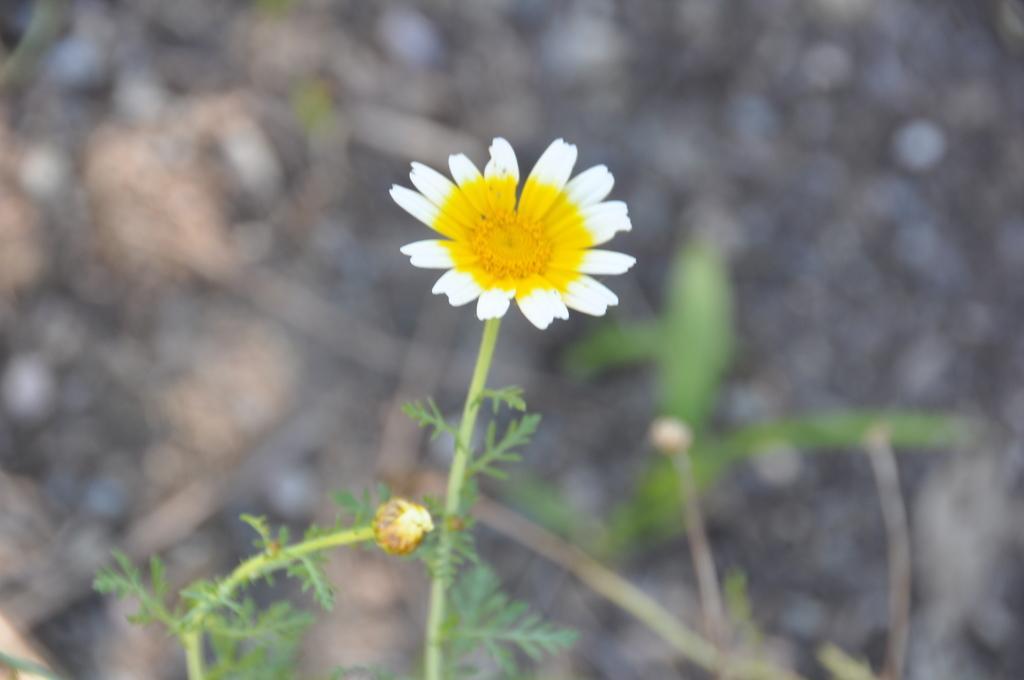Could you give a brief overview of what you see in this image? In this picture we can see a flower in the middle of the image, and we can find few plants. 